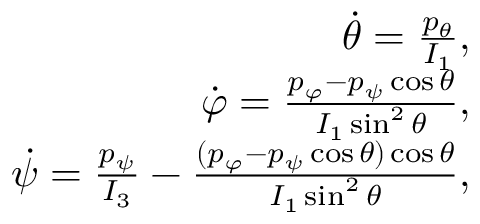Convert formula to latex. <formula><loc_0><loc_0><loc_500><loc_500>\begin{array} { r } { \dot { \theta } = \frac { p _ { \theta } } { I _ { 1 } } , } \\ { \dot { \varphi } = \frac { p _ { \varphi } - p _ { \psi } \cos \theta } { I _ { 1 } \sin ^ { 2 } \theta } , } \\ { \dot { \psi } = \frac { p _ { \psi } } { I _ { 3 } } - \frac { ( p _ { \varphi } - p _ { \psi } \cos \theta ) \cos \theta } { I _ { 1 } \sin ^ { 2 } \theta } , } \end{array}</formula> 